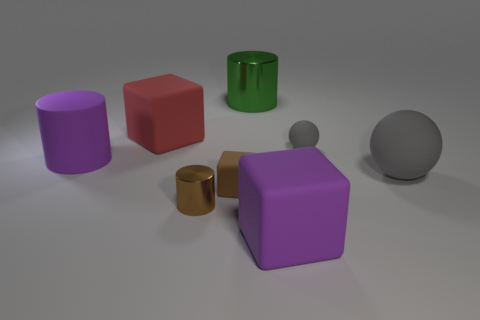Is there anything else that has the same shape as the tiny gray object?
Provide a succinct answer. Yes. What size is the purple matte object that is behind the purple matte block?
Offer a terse response. Large. How many other things are there of the same color as the small cube?
Give a very brief answer. 1. The purple cylinder behind the metal object that is in front of the big purple cylinder is made of what material?
Offer a terse response. Rubber. There is a tiny rubber thing in front of the big gray matte ball; is its color the same as the small shiny object?
Your answer should be compact. Yes. How many purple rubber things are the same shape as the small brown matte object?
Keep it short and to the point. 1. What size is the brown block that is the same material as the red block?
Provide a succinct answer. Small. There is a big rubber thing behind the big purple thing that is behind the large purple cube; are there any large cylinders behind it?
Give a very brief answer. Yes. Does the metal thing that is to the left of the green metal object have the same size as the brown matte thing?
Ensure brevity in your answer.  Yes. How many purple matte cubes have the same size as the brown rubber block?
Your answer should be compact. 0. 